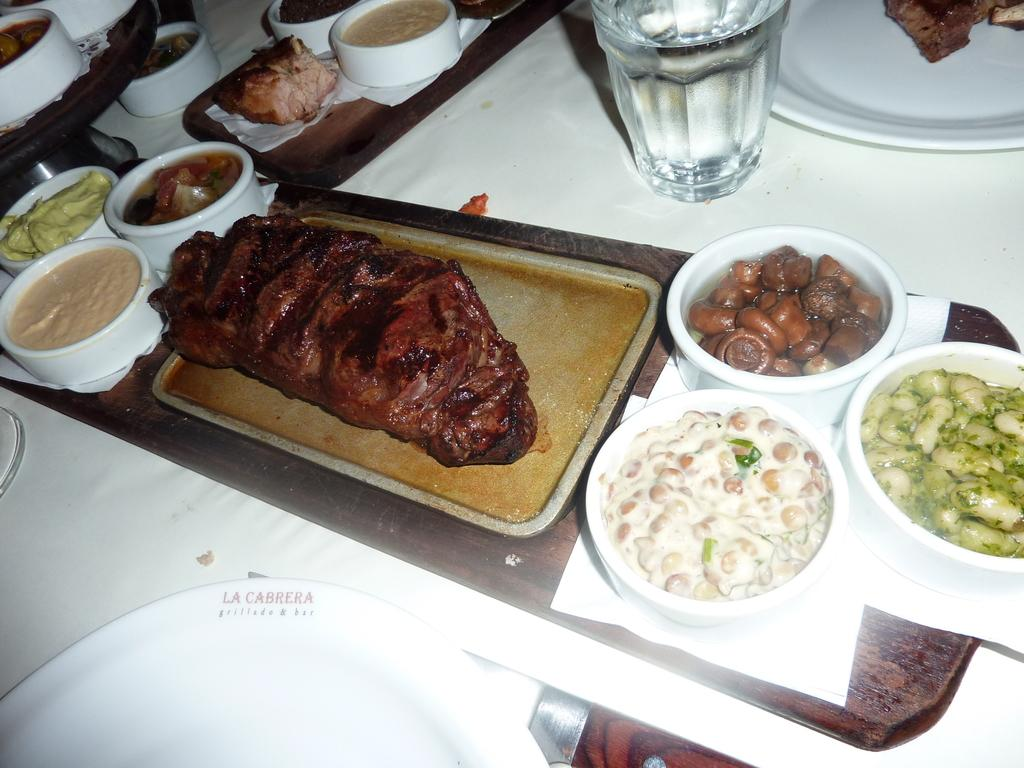What type of material is present in the image? The image contains flesh. What can be seen on a surface in the image? There are items on a table in the image. What is used for serving food in the image? There is a plate in the image. What is used for drinking in the image? There is a glass of water in the image. How many branches are visible in the image? There are no branches present in the image. What type of business is being conducted in the image? There is no indication of any business being conducted in the image. 